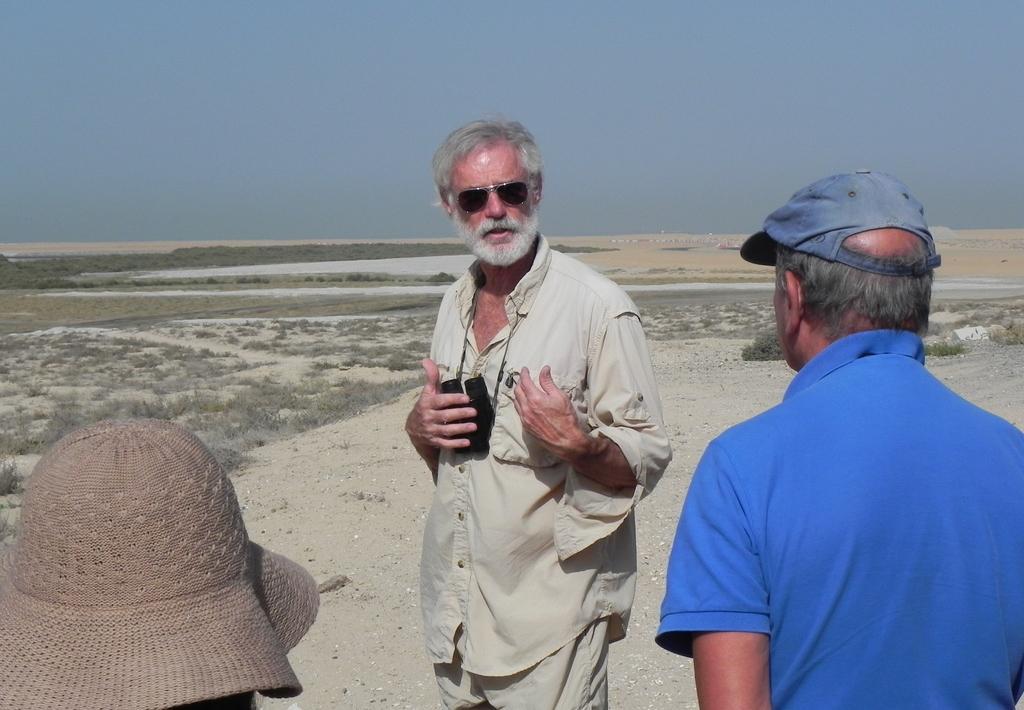Could you give a brief overview of what you see in this image? In this picture, we can see a few people, we can see the ground, we can see some dry plants, and the sky. 